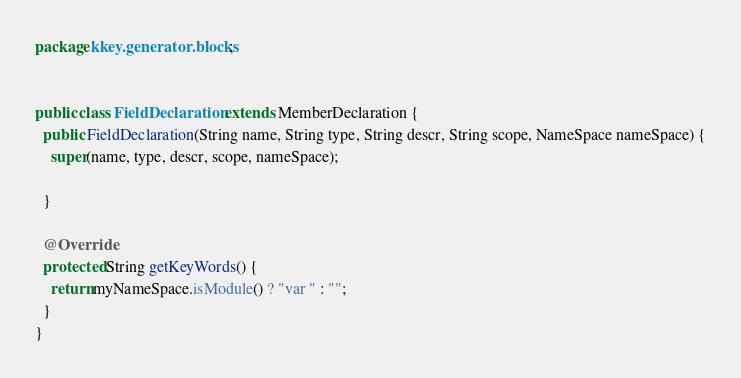Convert code to text. <code><loc_0><loc_0><loc_500><loc_500><_Java_>package kkey.generator.blocks;


public class FieldDeclaration extends MemberDeclaration {
  public FieldDeclaration(String name, String type, String descr, String scope, NameSpace nameSpace) {
    super(name, type, descr, scope, nameSpace);

  }

  @Override
  protected String getKeyWords() {
    return myNameSpace.isModule() ? "var " : "";
  }
}
</code> 